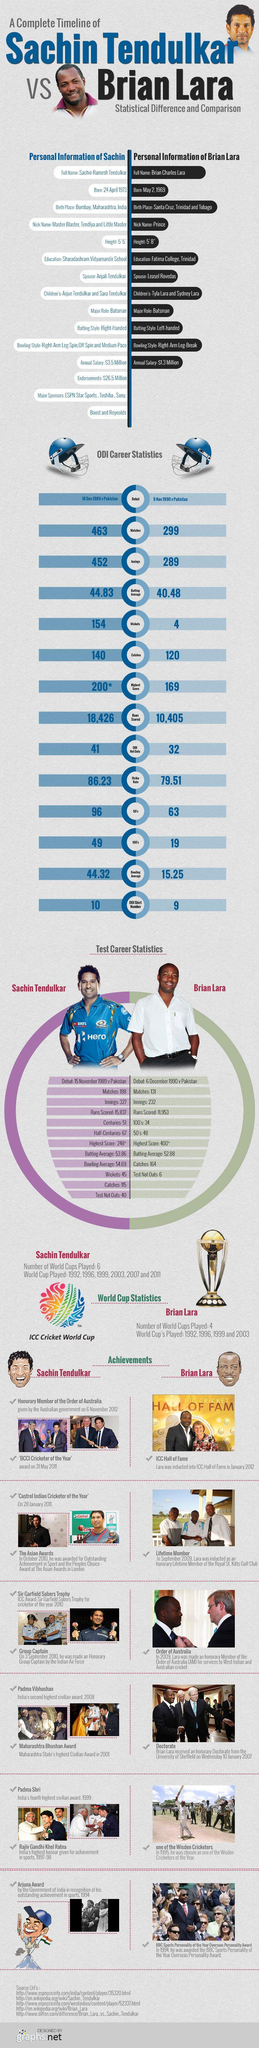What is the height of Sachin Tendulkar
Answer the question with a short phrase. 5'5" In the photographs, which cricketer is from India Sachin Tendulkar What is the batting average of Sachin Tendulkar 44.83 What is the total runs scored by Brian Lara and Sachin Tendulkar 28831 Which award is named after a great archer in India mythology Arjuna Award Which awards were awarded by K. R. Narayanan Padma Shri, Rajiv Gandhi Khel Ratna Who is a left-handed batsman Brian Lara In the photographs, which cricketer is from West Indies Brian Lara Which country did both Brian Lara and Sachin Tendulkar debut Pakistan 